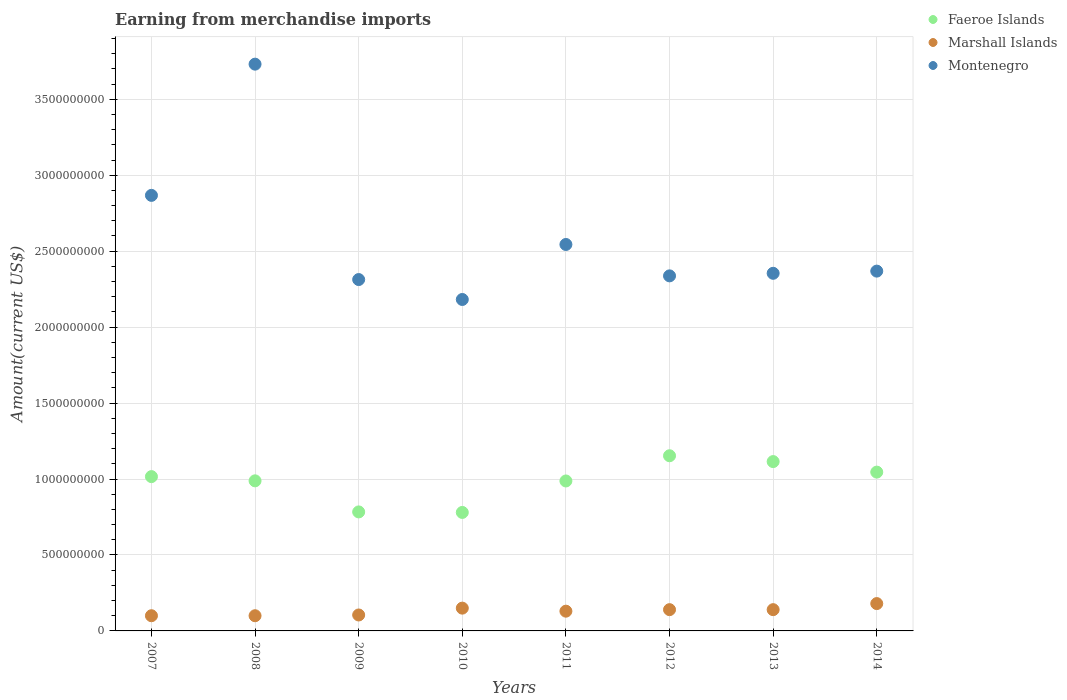How many different coloured dotlines are there?
Keep it short and to the point. 3. Is the number of dotlines equal to the number of legend labels?
Give a very brief answer. Yes. What is the amount earned from merchandise imports in Faeroe Islands in 2013?
Offer a terse response. 1.11e+09. Across all years, what is the maximum amount earned from merchandise imports in Marshall Islands?
Your answer should be compact. 1.80e+08. Across all years, what is the minimum amount earned from merchandise imports in Faeroe Islands?
Offer a very short reply. 7.80e+08. In which year was the amount earned from merchandise imports in Faeroe Islands maximum?
Give a very brief answer. 2012. In which year was the amount earned from merchandise imports in Marshall Islands minimum?
Provide a short and direct response. 2007. What is the total amount earned from merchandise imports in Marshall Islands in the graph?
Your answer should be very brief. 1.04e+09. What is the difference between the amount earned from merchandise imports in Marshall Islands in 2009 and that in 2014?
Make the answer very short. -7.50e+07. What is the difference between the amount earned from merchandise imports in Faeroe Islands in 2011 and the amount earned from merchandise imports in Marshall Islands in 2010?
Provide a short and direct response. 8.37e+08. What is the average amount earned from merchandise imports in Faeroe Islands per year?
Provide a short and direct response. 9.83e+08. In the year 2008, what is the difference between the amount earned from merchandise imports in Montenegro and amount earned from merchandise imports in Faeroe Islands?
Provide a short and direct response. 2.74e+09. What is the ratio of the amount earned from merchandise imports in Faeroe Islands in 2008 to that in 2014?
Make the answer very short. 0.95. Is the amount earned from merchandise imports in Montenegro in 2007 less than that in 2013?
Offer a terse response. No. Is the difference between the amount earned from merchandise imports in Montenegro in 2010 and 2011 greater than the difference between the amount earned from merchandise imports in Faeroe Islands in 2010 and 2011?
Make the answer very short. No. What is the difference between the highest and the second highest amount earned from merchandise imports in Faeroe Islands?
Offer a terse response. 3.84e+07. What is the difference between the highest and the lowest amount earned from merchandise imports in Faeroe Islands?
Provide a short and direct response. 3.73e+08. Is the sum of the amount earned from merchandise imports in Faeroe Islands in 2007 and 2014 greater than the maximum amount earned from merchandise imports in Montenegro across all years?
Provide a succinct answer. No. Is the amount earned from merchandise imports in Montenegro strictly less than the amount earned from merchandise imports in Marshall Islands over the years?
Make the answer very short. No. How many dotlines are there?
Provide a short and direct response. 3. What is the difference between two consecutive major ticks on the Y-axis?
Your answer should be compact. 5.00e+08. Where does the legend appear in the graph?
Give a very brief answer. Top right. How are the legend labels stacked?
Make the answer very short. Vertical. What is the title of the graph?
Keep it short and to the point. Earning from merchandise imports. What is the label or title of the Y-axis?
Keep it short and to the point. Amount(current US$). What is the Amount(current US$) in Faeroe Islands in 2007?
Provide a short and direct response. 1.02e+09. What is the Amount(current US$) in Montenegro in 2007?
Your response must be concise. 2.87e+09. What is the Amount(current US$) in Faeroe Islands in 2008?
Offer a very short reply. 9.88e+08. What is the Amount(current US$) of Montenegro in 2008?
Provide a short and direct response. 3.73e+09. What is the Amount(current US$) of Faeroe Islands in 2009?
Your answer should be compact. 7.83e+08. What is the Amount(current US$) in Marshall Islands in 2009?
Offer a terse response. 1.05e+08. What is the Amount(current US$) in Montenegro in 2009?
Your answer should be compact. 2.31e+09. What is the Amount(current US$) in Faeroe Islands in 2010?
Make the answer very short. 7.80e+08. What is the Amount(current US$) in Marshall Islands in 2010?
Make the answer very short. 1.50e+08. What is the Amount(current US$) in Montenegro in 2010?
Your answer should be compact. 2.18e+09. What is the Amount(current US$) in Faeroe Islands in 2011?
Offer a terse response. 9.87e+08. What is the Amount(current US$) in Marshall Islands in 2011?
Make the answer very short. 1.30e+08. What is the Amount(current US$) in Montenegro in 2011?
Offer a very short reply. 2.54e+09. What is the Amount(current US$) of Faeroe Islands in 2012?
Your response must be concise. 1.15e+09. What is the Amount(current US$) of Marshall Islands in 2012?
Keep it short and to the point. 1.40e+08. What is the Amount(current US$) in Montenegro in 2012?
Give a very brief answer. 2.34e+09. What is the Amount(current US$) of Faeroe Islands in 2013?
Ensure brevity in your answer.  1.11e+09. What is the Amount(current US$) in Marshall Islands in 2013?
Make the answer very short. 1.40e+08. What is the Amount(current US$) in Montenegro in 2013?
Keep it short and to the point. 2.35e+09. What is the Amount(current US$) in Faeroe Islands in 2014?
Offer a terse response. 1.05e+09. What is the Amount(current US$) in Marshall Islands in 2014?
Give a very brief answer. 1.80e+08. What is the Amount(current US$) of Montenegro in 2014?
Provide a succinct answer. 2.37e+09. Across all years, what is the maximum Amount(current US$) in Faeroe Islands?
Your answer should be compact. 1.15e+09. Across all years, what is the maximum Amount(current US$) of Marshall Islands?
Give a very brief answer. 1.80e+08. Across all years, what is the maximum Amount(current US$) in Montenegro?
Keep it short and to the point. 3.73e+09. Across all years, what is the minimum Amount(current US$) in Faeroe Islands?
Give a very brief answer. 7.80e+08. Across all years, what is the minimum Amount(current US$) in Marshall Islands?
Provide a succinct answer. 1.00e+08. Across all years, what is the minimum Amount(current US$) of Montenegro?
Give a very brief answer. 2.18e+09. What is the total Amount(current US$) in Faeroe Islands in the graph?
Offer a terse response. 7.87e+09. What is the total Amount(current US$) in Marshall Islands in the graph?
Your response must be concise. 1.04e+09. What is the total Amount(current US$) of Montenegro in the graph?
Your answer should be compact. 2.07e+1. What is the difference between the Amount(current US$) of Faeroe Islands in 2007 and that in 2008?
Ensure brevity in your answer.  2.78e+07. What is the difference between the Amount(current US$) of Montenegro in 2007 and that in 2008?
Ensure brevity in your answer.  -8.64e+08. What is the difference between the Amount(current US$) in Faeroe Islands in 2007 and that in 2009?
Make the answer very short. 2.32e+08. What is the difference between the Amount(current US$) of Marshall Islands in 2007 and that in 2009?
Provide a succinct answer. -5.00e+06. What is the difference between the Amount(current US$) of Montenegro in 2007 and that in 2009?
Offer a very short reply. 5.54e+08. What is the difference between the Amount(current US$) of Faeroe Islands in 2007 and that in 2010?
Provide a short and direct response. 2.36e+08. What is the difference between the Amount(current US$) of Marshall Islands in 2007 and that in 2010?
Your answer should be very brief. -5.00e+07. What is the difference between the Amount(current US$) in Montenegro in 2007 and that in 2010?
Your answer should be compact. 6.85e+08. What is the difference between the Amount(current US$) of Faeroe Islands in 2007 and that in 2011?
Ensure brevity in your answer.  2.86e+07. What is the difference between the Amount(current US$) of Marshall Islands in 2007 and that in 2011?
Your answer should be compact. -3.00e+07. What is the difference between the Amount(current US$) of Montenegro in 2007 and that in 2011?
Provide a succinct answer. 3.23e+08. What is the difference between the Amount(current US$) of Faeroe Islands in 2007 and that in 2012?
Your answer should be very brief. -1.37e+08. What is the difference between the Amount(current US$) in Marshall Islands in 2007 and that in 2012?
Your answer should be very brief. -4.00e+07. What is the difference between the Amount(current US$) of Montenegro in 2007 and that in 2012?
Keep it short and to the point. 5.30e+08. What is the difference between the Amount(current US$) in Faeroe Islands in 2007 and that in 2013?
Your answer should be compact. -9.89e+07. What is the difference between the Amount(current US$) of Marshall Islands in 2007 and that in 2013?
Keep it short and to the point. -4.00e+07. What is the difference between the Amount(current US$) in Montenegro in 2007 and that in 2013?
Your answer should be very brief. 5.13e+08. What is the difference between the Amount(current US$) in Faeroe Islands in 2007 and that in 2014?
Ensure brevity in your answer.  -2.96e+07. What is the difference between the Amount(current US$) in Marshall Islands in 2007 and that in 2014?
Make the answer very short. -8.00e+07. What is the difference between the Amount(current US$) of Montenegro in 2007 and that in 2014?
Provide a succinct answer. 4.99e+08. What is the difference between the Amount(current US$) of Faeroe Islands in 2008 and that in 2009?
Give a very brief answer. 2.05e+08. What is the difference between the Amount(current US$) in Marshall Islands in 2008 and that in 2009?
Your answer should be very brief. -5.00e+06. What is the difference between the Amount(current US$) of Montenegro in 2008 and that in 2009?
Provide a short and direct response. 1.42e+09. What is the difference between the Amount(current US$) of Faeroe Islands in 2008 and that in 2010?
Make the answer very short. 2.08e+08. What is the difference between the Amount(current US$) of Marshall Islands in 2008 and that in 2010?
Provide a succinct answer. -5.00e+07. What is the difference between the Amount(current US$) in Montenegro in 2008 and that in 2010?
Make the answer very short. 1.55e+09. What is the difference between the Amount(current US$) in Faeroe Islands in 2008 and that in 2011?
Offer a terse response. 8.75e+05. What is the difference between the Amount(current US$) of Marshall Islands in 2008 and that in 2011?
Your answer should be very brief. -3.00e+07. What is the difference between the Amount(current US$) in Montenegro in 2008 and that in 2011?
Offer a very short reply. 1.19e+09. What is the difference between the Amount(current US$) of Faeroe Islands in 2008 and that in 2012?
Your response must be concise. -1.65e+08. What is the difference between the Amount(current US$) of Marshall Islands in 2008 and that in 2012?
Your response must be concise. -4.00e+07. What is the difference between the Amount(current US$) of Montenegro in 2008 and that in 2012?
Offer a very short reply. 1.39e+09. What is the difference between the Amount(current US$) of Faeroe Islands in 2008 and that in 2013?
Give a very brief answer. -1.27e+08. What is the difference between the Amount(current US$) of Marshall Islands in 2008 and that in 2013?
Your answer should be compact. -4.00e+07. What is the difference between the Amount(current US$) of Montenegro in 2008 and that in 2013?
Give a very brief answer. 1.38e+09. What is the difference between the Amount(current US$) of Faeroe Islands in 2008 and that in 2014?
Your answer should be compact. -5.74e+07. What is the difference between the Amount(current US$) of Marshall Islands in 2008 and that in 2014?
Give a very brief answer. -8.00e+07. What is the difference between the Amount(current US$) of Montenegro in 2008 and that in 2014?
Give a very brief answer. 1.36e+09. What is the difference between the Amount(current US$) of Faeroe Islands in 2009 and that in 2010?
Keep it short and to the point. 3.42e+06. What is the difference between the Amount(current US$) in Marshall Islands in 2009 and that in 2010?
Provide a short and direct response. -4.50e+07. What is the difference between the Amount(current US$) of Montenegro in 2009 and that in 2010?
Provide a succinct answer. 1.31e+08. What is the difference between the Amount(current US$) of Faeroe Islands in 2009 and that in 2011?
Keep it short and to the point. -2.04e+08. What is the difference between the Amount(current US$) of Marshall Islands in 2009 and that in 2011?
Provide a succinct answer. -2.50e+07. What is the difference between the Amount(current US$) in Montenegro in 2009 and that in 2011?
Offer a very short reply. -2.31e+08. What is the difference between the Amount(current US$) in Faeroe Islands in 2009 and that in 2012?
Provide a short and direct response. -3.70e+08. What is the difference between the Amount(current US$) of Marshall Islands in 2009 and that in 2012?
Provide a short and direct response. -3.50e+07. What is the difference between the Amount(current US$) in Montenegro in 2009 and that in 2012?
Your answer should be very brief. -2.43e+07. What is the difference between the Amount(current US$) of Faeroe Islands in 2009 and that in 2013?
Ensure brevity in your answer.  -3.31e+08. What is the difference between the Amount(current US$) in Marshall Islands in 2009 and that in 2013?
Your response must be concise. -3.50e+07. What is the difference between the Amount(current US$) in Montenegro in 2009 and that in 2013?
Make the answer very short. -4.11e+07. What is the difference between the Amount(current US$) of Faeroe Islands in 2009 and that in 2014?
Keep it short and to the point. -2.62e+08. What is the difference between the Amount(current US$) in Marshall Islands in 2009 and that in 2014?
Make the answer very short. -7.50e+07. What is the difference between the Amount(current US$) of Montenegro in 2009 and that in 2014?
Offer a terse response. -5.56e+07. What is the difference between the Amount(current US$) in Faeroe Islands in 2010 and that in 2011?
Keep it short and to the point. -2.07e+08. What is the difference between the Amount(current US$) of Montenegro in 2010 and that in 2011?
Give a very brief answer. -3.62e+08. What is the difference between the Amount(current US$) in Faeroe Islands in 2010 and that in 2012?
Your response must be concise. -3.73e+08. What is the difference between the Amount(current US$) of Montenegro in 2010 and that in 2012?
Ensure brevity in your answer.  -1.55e+08. What is the difference between the Amount(current US$) in Faeroe Islands in 2010 and that in 2013?
Provide a succinct answer. -3.35e+08. What is the difference between the Amount(current US$) in Marshall Islands in 2010 and that in 2013?
Give a very brief answer. 1.00e+07. What is the difference between the Amount(current US$) of Montenegro in 2010 and that in 2013?
Give a very brief answer. -1.72e+08. What is the difference between the Amount(current US$) in Faeroe Islands in 2010 and that in 2014?
Your response must be concise. -2.65e+08. What is the difference between the Amount(current US$) of Marshall Islands in 2010 and that in 2014?
Keep it short and to the point. -3.00e+07. What is the difference between the Amount(current US$) in Montenegro in 2010 and that in 2014?
Offer a terse response. -1.87e+08. What is the difference between the Amount(current US$) of Faeroe Islands in 2011 and that in 2012?
Give a very brief answer. -1.66e+08. What is the difference between the Amount(current US$) of Marshall Islands in 2011 and that in 2012?
Provide a succinct answer. -1.00e+07. What is the difference between the Amount(current US$) of Montenegro in 2011 and that in 2012?
Offer a very short reply. 2.07e+08. What is the difference between the Amount(current US$) in Faeroe Islands in 2011 and that in 2013?
Keep it short and to the point. -1.28e+08. What is the difference between the Amount(current US$) of Marshall Islands in 2011 and that in 2013?
Offer a very short reply. -1.00e+07. What is the difference between the Amount(current US$) of Montenegro in 2011 and that in 2013?
Provide a succinct answer. 1.90e+08. What is the difference between the Amount(current US$) in Faeroe Islands in 2011 and that in 2014?
Your answer should be compact. -5.82e+07. What is the difference between the Amount(current US$) in Marshall Islands in 2011 and that in 2014?
Provide a short and direct response. -5.00e+07. What is the difference between the Amount(current US$) in Montenegro in 2011 and that in 2014?
Your response must be concise. 1.75e+08. What is the difference between the Amount(current US$) in Faeroe Islands in 2012 and that in 2013?
Your response must be concise. 3.84e+07. What is the difference between the Amount(current US$) of Montenegro in 2012 and that in 2013?
Give a very brief answer. -1.69e+07. What is the difference between the Amount(current US$) in Faeroe Islands in 2012 and that in 2014?
Provide a succinct answer. 1.08e+08. What is the difference between the Amount(current US$) in Marshall Islands in 2012 and that in 2014?
Offer a terse response. -4.00e+07. What is the difference between the Amount(current US$) in Montenegro in 2012 and that in 2014?
Provide a succinct answer. -3.13e+07. What is the difference between the Amount(current US$) of Faeroe Islands in 2013 and that in 2014?
Offer a very short reply. 6.93e+07. What is the difference between the Amount(current US$) of Marshall Islands in 2013 and that in 2014?
Your response must be concise. -4.00e+07. What is the difference between the Amount(current US$) of Montenegro in 2013 and that in 2014?
Your response must be concise. -1.44e+07. What is the difference between the Amount(current US$) in Faeroe Islands in 2007 and the Amount(current US$) in Marshall Islands in 2008?
Your response must be concise. 9.16e+08. What is the difference between the Amount(current US$) in Faeroe Islands in 2007 and the Amount(current US$) in Montenegro in 2008?
Keep it short and to the point. -2.72e+09. What is the difference between the Amount(current US$) of Marshall Islands in 2007 and the Amount(current US$) of Montenegro in 2008?
Your answer should be compact. -3.63e+09. What is the difference between the Amount(current US$) in Faeroe Islands in 2007 and the Amount(current US$) in Marshall Islands in 2009?
Keep it short and to the point. 9.11e+08. What is the difference between the Amount(current US$) in Faeroe Islands in 2007 and the Amount(current US$) in Montenegro in 2009?
Offer a very short reply. -1.30e+09. What is the difference between the Amount(current US$) in Marshall Islands in 2007 and the Amount(current US$) in Montenegro in 2009?
Ensure brevity in your answer.  -2.21e+09. What is the difference between the Amount(current US$) in Faeroe Islands in 2007 and the Amount(current US$) in Marshall Islands in 2010?
Offer a terse response. 8.66e+08. What is the difference between the Amount(current US$) in Faeroe Islands in 2007 and the Amount(current US$) in Montenegro in 2010?
Keep it short and to the point. -1.17e+09. What is the difference between the Amount(current US$) of Marshall Islands in 2007 and the Amount(current US$) of Montenegro in 2010?
Offer a very short reply. -2.08e+09. What is the difference between the Amount(current US$) of Faeroe Islands in 2007 and the Amount(current US$) of Marshall Islands in 2011?
Offer a terse response. 8.86e+08. What is the difference between the Amount(current US$) of Faeroe Islands in 2007 and the Amount(current US$) of Montenegro in 2011?
Provide a succinct answer. -1.53e+09. What is the difference between the Amount(current US$) of Marshall Islands in 2007 and the Amount(current US$) of Montenegro in 2011?
Your answer should be compact. -2.44e+09. What is the difference between the Amount(current US$) of Faeroe Islands in 2007 and the Amount(current US$) of Marshall Islands in 2012?
Ensure brevity in your answer.  8.76e+08. What is the difference between the Amount(current US$) in Faeroe Islands in 2007 and the Amount(current US$) in Montenegro in 2012?
Make the answer very short. -1.32e+09. What is the difference between the Amount(current US$) in Marshall Islands in 2007 and the Amount(current US$) in Montenegro in 2012?
Provide a succinct answer. -2.24e+09. What is the difference between the Amount(current US$) in Faeroe Islands in 2007 and the Amount(current US$) in Marshall Islands in 2013?
Your response must be concise. 8.76e+08. What is the difference between the Amount(current US$) of Faeroe Islands in 2007 and the Amount(current US$) of Montenegro in 2013?
Give a very brief answer. -1.34e+09. What is the difference between the Amount(current US$) of Marshall Islands in 2007 and the Amount(current US$) of Montenegro in 2013?
Your answer should be very brief. -2.25e+09. What is the difference between the Amount(current US$) of Faeroe Islands in 2007 and the Amount(current US$) of Marshall Islands in 2014?
Keep it short and to the point. 8.36e+08. What is the difference between the Amount(current US$) in Faeroe Islands in 2007 and the Amount(current US$) in Montenegro in 2014?
Offer a terse response. -1.35e+09. What is the difference between the Amount(current US$) in Marshall Islands in 2007 and the Amount(current US$) in Montenegro in 2014?
Make the answer very short. -2.27e+09. What is the difference between the Amount(current US$) of Faeroe Islands in 2008 and the Amount(current US$) of Marshall Islands in 2009?
Your response must be concise. 8.83e+08. What is the difference between the Amount(current US$) in Faeroe Islands in 2008 and the Amount(current US$) in Montenegro in 2009?
Your answer should be very brief. -1.33e+09. What is the difference between the Amount(current US$) in Marshall Islands in 2008 and the Amount(current US$) in Montenegro in 2009?
Ensure brevity in your answer.  -2.21e+09. What is the difference between the Amount(current US$) in Faeroe Islands in 2008 and the Amount(current US$) in Marshall Islands in 2010?
Offer a very short reply. 8.38e+08. What is the difference between the Amount(current US$) in Faeroe Islands in 2008 and the Amount(current US$) in Montenegro in 2010?
Make the answer very short. -1.19e+09. What is the difference between the Amount(current US$) in Marshall Islands in 2008 and the Amount(current US$) in Montenegro in 2010?
Provide a succinct answer. -2.08e+09. What is the difference between the Amount(current US$) of Faeroe Islands in 2008 and the Amount(current US$) of Marshall Islands in 2011?
Your answer should be very brief. 8.58e+08. What is the difference between the Amount(current US$) in Faeroe Islands in 2008 and the Amount(current US$) in Montenegro in 2011?
Keep it short and to the point. -1.56e+09. What is the difference between the Amount(current US$) in Marshall Islands in 2008 and the Amount(current US$) in Montenegro in 2011?
Keep it short and to the point. -2.44e+09. What is the difference between the Amount(current US$) in Faeroe Islands in 2008 and the Amount(current US$) in Marshall Islands in 2012?
Your answer should be compact. 8.48e+08. What is the difference between the Amount(current US$) of Faeroe Islands in 2008 and the Amount(current US$) of Montenegro in 2012?
Make the answer very short. -1.35e+09. What is the difference between the Amount(current US$) in Marshall Islands in 2008 and the Amount(current US$) in Montenegro in 2012?
Give a very brief answer. -2.24e+09. What is the difference between the Amount(current US$) in Faeroe Islands in 2008 and the Amount(current US$) in Marshall Islands in 2013?
Your response must be concise. 8.48e+08. What is the difference between the Amount(current US$) in Faeroe Islands in 2008 and the Amount(current US$) in Montenegro in 2013?
Your response must be concise. -1.37e+09. What is the difference between the Amount(current US$) of Marshall Islands in 2008 and the Amount(current US$) of Montenegro in 2013?
Offer a terse response. -2.25e+09. What is the difference between the Amount(current US$) of Faeroe Islands in 2008 and the Amount(current US$) of Marshall Islands in 2014?
Ensure brevity in your answer.  8.08e+08. What is the difference between the Amount(current US$) in Faeroe Islands in 2008 and the Amount(current US$) in Montenegro in 2014?
Provide a short and direct response. -1.38e+09. What is the difference between the Amount(current US$) in Marshall Islands in 2008 and the Amount(current US$) in Montenegro in 2014?
Offer a terse response. -2.27e+09. What is the difference between the Amount(current US$) in Faeroe Islands in 2009 and the Amount(current US$) in Marshall Islands in 2010?
Give a very brief answer. 6.33e+08. What is the difference between the Amount(current US$) in Faeroe Islands in 2009 and the Amount(current US$) in Montenegro in 2010?
Your response must be concise. -1.40e+09. What is the difference between the Amount(current US$) of Marshall Islands in 2009 and the Amount(current US$) of Montenegro in 2010?
Provide a succinct answer. -2.08e+09. What is the difference between the Amount(current US$) of Faeroe Islands in 2009 and the Amount(current US$) of Marshall Islands in 2011?
Give a very brief answer. 6.53e+08. What is the difference between the Amount(current US$) of Faeroe Islands in 2009 and the Amount(current US$) of Montenegro in 2011?
Your response must be concise. -1.76e+09. What is the difference between the Amount(current US$) of Marshall Islands in 2009 and the Amount(current US$) of Montenegro in 2011?
Your answer should be very brief. -2.44e+09. What is the difference between the Amount(current US$) in Faeroe Islands in 2009 and the Amount(current US$) in Marshall Islands in 2012?
Provide a succinct answer. 6.43e+08. What is the difference between the Amount(current US$) of Faeroe Islands in 2009 and the Amount(current US$) of Montenegro in 2012?
Make the answer very short. -1.55e+09. What is the difference between the Amount(current US$) in Marshall Islands in 2009 and the Amount(current US$) in Montenegro in 2012?
Your answer should be very brief. -2.23e+09. What is the difference between the Amount(current US$) of Faeroe Islands in 2009 and the Amount(current US$) of Marshall Islands in 2013?
Your answer should be very brief. 6.43e+08. What is the difference between the Amount(current US$) in Faeroe Islands in 2009 and the Amount(current US$) in Montenegro in 2013?
Provide a succinct answer. -1.57e+09. What is the difference between the Amount(current US$) of Marshall Islands in 2009 and the Amount(current US$) of Montenegro in 2013?
Give a very brief answer. -2.25e+09. What is the difference between the Amount(current US$) of Faeroe Islands in 2009 and the Amount(current US$) of Marshall Islands in 2014?
Give a very brief answer. 6.03e+08. What is the difference between the Amount(current US$) in Faeroe Islands in 2009 and the Amount(current US$) in Montenegro in 2014?
Provide a succinct answer. -1.59e+09. What is the difference between the Amount(current US$) of Marshall Islands in 2009 and the Amount(current US$) of Montenegro in 2014?
Provide a succinct answer. -2.26e+09. What is the difference between the Amount(current US$) in Faeroe Islands in 2010 and the Amount(current US$) in Marshall Islands in 2011?
Offer a terse response. 6.50e+08. What is the difference between the Amount(current US$) in Faeroe Islands in 2010 and the Amount(current US$) in Montenegro in 2011?
Keep it short and to the point. -1.76e+09. What is the difference between the Amount(current US$) in Marshall Islands in 2010 and the Amount(current US$) in Montenegro in 2011?
Your response must be concise. -2.39e+09. What is the difference between the Amount(current US$) of Faeroe Islands in 2010 and the Amount(current US$) of Marshall Islands in 2012?
Your answer should be compact. 6.40e+08. What is the difference between the Amount(current US$) in Faeroe Islands in 2010 and the Amount(current US$) in Montenegro in 2012?
Offer a very short reply. -1.56e+09. What is the difference between the Amount(current US$) in Marshall Islands in 2010 and the Amount(current US$) in Montenegro in 2012?
Your answer should be very brief. -2.19e+09. What is the difference between the Amount(current US$) in Faeroe Islands in 2010 and the Amount(current US$) in Marshall Islands in 2013?
Offer a terse response. 6.40e+08. What is the difference between the Amount(current US$) of Faeroe Islands in 2010 and the Amount(current US$) of Montenegro in 2013?
Offer a very short reply. -1.57e+09. What is the difference between the Amount(current US$) in Marshall Islands in 2010 and the Amount(current US$) in Montenegro in 2013?
Keep it short and to the point. -2.20e+09. What is the difference between the Amount(current US$) of Faeroe Islands in 2010 and the Amount(current US$) of Marshall Islands in 2014?
Your answer should be very brief. 6.00e+08. What is the difference between the Amount(current US$) in Faeroe Islands in 2010 and the Amount(current US$) in Montenegro in 2014?
Offer a terse response. -1.59e+09. What is the difference between the Amount(current US$) in Marshall Islands in 2010 and the Amount(current US$) in Montenegro in 2014?
Make the answer very short. -2.22e+09. What is the difference between the Amount(current US$) of Faeroe Islands in 2011 and the Amount(current US$) of Marshall Islands in 2012?
Ensure brevity in your answer.  8.47e+08. What is the difference between the Amount(current US$) in Faeroe Islands in 2011 and the Amount(current US$) in Montenegro in 2012?
Your answer should be compact. -1.35e+09. What is the difference between the Amount(current US$) in Marshall Islands in 2011 and the Amount(current US$) in Montenegro in 2012?
Your response must be concise. -2.21e+09. What is the difference between the Amount(current US$) of Faeroe Islands in 2011 and the Amount(current US$) of Marshall Islands in 2013?
Your answer should be very brief. 8.47e+08. What is the difference between the Amount(current US$) in Faeroe Islands in 2011 and the Amount(current US$) in Montenegro in 2013?
Your answer should be compact. -1.37e+09. What is the difference between the Amount(current US$) of Marshall Islands in 2011 and the Amount(current US$) of Montenegro in 2013?
Your response must be concise. -2.22e+09. What is the difference between the Amount(current US$) in Faeroe Islands in 2011 and the Amount(current US$) in Marshall Islands in 2014?
Make the answer very short. 8.07e+08. What is the difference between the Amount(current US$) in Faeroe Islands in 2011 and the Amount(current US$) in Montenegro in 2014?
Give a very brief answer. -1.38e+09. What is the difference between the Amount(current US$) in Marshall Islands in 2011 and the Amount(current US$) in Montenegro in 2014?
Offer a terse response. -2.24e+09. What is the difference between the Amount(current US$) of Faeroe Islands in 2012 and the Amount(current US$) of Marshall Islands in 2013?
Keep it short and to the point. 1.01e+09. What is the difference between the Amount(current US$) of Faeroe Islands in 2012 and the Amount(current US$) of Montenegro in 2013?
Make the answer very short. -1.20e+09. What is the difference between the Amount(current US$) of Marshall Islands in 2012 and the Amount(current US$) of Montenegro in 2013?
Provide a short and direct response. -2.21e+09. What is the difference between the Amount(current US$) in Faeroe Islands in 2012 and the Amount(current US$) in Marshall Islands in 2014?
Offer a very short reply. 9.73e+08. What is the difference between the Amount(current US$) of Faeroe Islands in 2012 and the Amount(current US$) of Montenegro in 2014?
Give a very brief answer. -1.22e+09. What is the difference between the Amount(current US$) in Marshall Islands in 2012 and the Amount(current US$) in Montenegro in 2014?
Offer a terse response. -2.23e+09. What is the difference between the Amount(current US$) in Faeroe Islands in 2013 and the Amount(current US$) in Marshall Islands in 2014?
Ensure brevity in your answer.  9.35e+08. What is the difference between the Amount(current US$) in Faeroe Islands in 2013 and the Amount(current US$) in Montenegro in 2014?
Ensure brevity in your answer.  -1.25e+09. What is the difference between the Amount(current US$) in Marshall Islands in 2013 and the Amount(current US$) in Montenegro in 2014?
Give a very brief answer. -2.23e+09. What is the average Amount(current US$) in Faeroe Islands per year?
Your answer should be very brief. 9.83e+08. What is the average Amount(current US$) of Marshall Islands per year?
Make the answer very short. 1.31e+08. What is the average Amount(current US$) of Montenegro per year?
Provide a short and direct response. 2.59e+09. In the year 2007, what is the difference between the Amount(current US$) of Faeroe Islands and Amount(current US$) of Marshall Islands?
Provide a short and direct response. 9.16e+08. In the year 2007, what is the difference between the Amount(current US$) of Faeroe Islands and Amount(current US$) of Montenegro?
Your response must be concise. -1.85e+09. In the year 2007, what is the difference between the Amount(current US$) of Marshall Islands and Amount(current US$) of Montenegro?
Offer a very short reply. -2.77e+09. In the year 2008, what is the difference between the Amount(current US$) in Faeroe Islands and Amount(current US$) in Marshall Islands?
Offer a very short reply. 8.88e+08. In the year 2008, what is the difference between the Amount(current US$) in Faeroe Islands and Amount(current US$) in Montenegro?
Give a very brief answer. -2.74e+09. In the year 2008, what is the difference between the Amount(current US$) of Marshall Islands and Amount(current US$) of Montenegro?
Offer a terse response. -3.63e+09. In the year 2009, what is the difference between the Amount(current US$) in Faeroe Islands and Amount(current US$) in Marshall Islands?
Provide a short and direct response. 6.78e+08. In the year 2009, what is the difference between the Amount(current US$) of Faeroe Islands and Amount(current US$) of Montenegro?
Provide a short and direct response. -1.53e+09. In the year 2009, what is the difference between the Amount(current US$) in Marshall Islands and Amount(current US$) in Montenegro?
Your answer should be compact. -2.21e+09. In the year 2010, what is the difference between the Amount(current US$) of Faeroe Islands and Amount(current US$) of Marshall Islands?
Give a very brief answer. 6.30e+08. In the year 2010, what is the difference between the Amount(current US$) of Faeroe Islands and Amount(current US$) of Montenegro?
Your answer should be very brief. -1.40e+09. In the year 2010, what is the difference between the Amount(current US$) of Marshall Islands and Amount(current US$) of Montenegro?
Give a very brief answer. -2.03e+09. In the year 2011, what is the difference between the Amount(current US$) of Faeroe Islands and Amount(current US$) of Marshall Islands?
Offer a terse response. 8.57e+08. In the year 2011, what is the difference between the Amount(current US$) in Faeroe Islands and Amount(current US$) in Montenegro?
Your answer should be very brief. -1.56e+09. In the year 2011, what is the difference between the Amount(current US$) of Marshall Islands and Amount(current US$) of Montenegro?
Give a very brief answer. -2.41e+09. In the year 2012, what is the difference between the Amount(current US$) in Faeroe Islands and Amount(current US$) in Marshall Islands?
Offer a very short reply. 1.01e+09. In the year 2012, what is the difference between the Amount(current US$) in Faeroe Islands and Amount(current US$) in Montenegro?
Keep it short and to the point. -1.18e+09. In the year 2012, what is the difference between the Amount(current US$) of Marshall Islands and Amount(current US$) of Montenegro?
Offer a terse response. -2.20e+09. In the year 2013, what is the difference between the Amount(current US$) of Faeroe Islands and Amount(current US$) of Marshall Islands?
Provide a succinct answer. 9.75e+08. In the year 2013, what is the difference between the Amount(current US$) of Faeroe Islands and Amount(current US$) of Montenegro?
Provide a short and direct response. -1.24e+09. In the year 2013, what is the difference between the Amount(current US$) in Marshall Islands and Amount(current US$) in Montenegro?
Keep it short and to the point. -2.21e+09. In the year 2014, what is the difference between the Amount(current US$) of Faeroe Islands and Amount(current US$) of Marshall Islands?
Offer a terse response. 8.65e+08. In the year 2014, what is the difference between the Amount(current US$) of Faeroe Islands and Amount(current US$) of Montenegro?
Provide a succinct answer. -1.32e+09. In the year 2014, what is the difference between the Amount(current US$) in Marshall Islands and Amount(current US$) in Montenegro?
Your answer should be compact. -2.19e+09. What is the ratio of the Amount(current US$) in Faeroe Islands in 2007 to that in 2008?
Make the answer very short. 1.03. What is the ratio of the Amount(current US$) of Montenegro in 2007 to that in 2008?
Your answer should be very brief. 0.77. What is the ratio of the Amount(current US$) of Faeroe Islands in 2007 to that in 2009?
Make the answer very short. 1.3. What is the ratio of the Amount(current US$) in Montenegro in 2007 to that in 2009?
Your answer should be very brief. 1.24. What is the ratio of the Amount(current US$) of Faeroe Islands in 2007 to that in 2010?
Give a very brief answer. 1.3. What is the ratio of the Amount(current US$) of Montenegro in 2007 to that in 2010?
Make the answer very short. 1.31. What is the ratio of the Amount(current US$) in Marshall Islands in 2007 to that in 2011?
Make the answer very short. 0.77. What is the ratio of the Amount(current US$) of Montenegro in 2007 to that in 2011?
Your answer should be very brief. 1.13. What is the ratio of the Amount(current US$) in Faeroe Islands in 2007 to that in 2012?
Keep it short and to the point. 0.88. What is the ratio of the Amount(current US$) in Marshall Islands in 2007 to that in 2012?
Your answer should be compact. 0.71. What is the ratio of the Amount(current US$) of Montenegro in 2007 to that in 2012?
Offer a terse response. 1.23. What is the ratio of the Amount(current US$) of Faeroe Islands in 2007 to that in 2013?
Offer a very short reply. 0.91. What is the ratio of the Amount(current US$) of Marshall Islands in 2007 to that in 2013?
Your response must be concise. 0.71. What is the ratio of the Amount(current US$) of Montenegro in 2007 to that in 2013?
Your answer should be compact. 1.22. What is the ratio of the Amount(current US$) of Faeroe Islands in 2007 to that in 2014?
Your response must be concise. 0.97. What is the ratio of the Amount(current US$) in Marshall Islands in 2007 to that in 2014?
Your response must be concise. 0.56. What is the ratio of the Amount(current US$) in Montenegro in 2007 to that in 2014?
Offer a terse response. 1.21. What is the ratio of the Amount(current US$) of Faeroe Islands in 2008 to that in 2009?
Your answer should be compact. 1.26. What is the ratio of the Amount(current US$) of Marshall Islands in 2008 to that in 2009?
Offer a terse response. 0.95. What is the ratio of the Amount(current US$) of Montenegro in 2008 to that in 2009?
Make the answer very short. 1.61. What is the ratio of the Amount(current US$) in Faeroe Islands in 2008 to that in 2010?
Offer a very short reply. 1.27. What is the ratio of the Amount(current US$) in Marshall Islands in 2008 to that in 2010?
Your answer should be compact. 0.67. What is the ratio of the Amount(current US$) in Montenegro in 2008 to that in 2010?
Keep it short and to the point. 1.71. What is the ratio of the Amount(current US$) of Faeroe Islands in 2008 to that in 2011?
Provide a short and direct response. 1. What is the ratio of the Amount(current US$) in Marshall Islands in 2008 to that in 2011?
Give a very brief answer. 0.77. What is the ratio of the Amount(current US$) of Montenegro in 2008 to that in 2011?
Provide a short and direct response. 1.47. What is the ratio of the Amount(current US$) of Faeroe Islands in 2008 to that in 2012?
Ensure brevity in your answer.  0.86. What is the ratio of the Amount(current US$) of Marshall Islands in 2008 to that in 2012?
Offer a terse response. 0.71. What is the ratio of the Amount(current US$) in Montenegro in 2008 to that in 2012?
Your answer should be compact. 1.6. What is the ratio of the Amount(current US$) in Faeroe Islands in 2008 to that in 2013?
Your answer should be very brief. 0.89. What is the ratio of the Amount(current US$) in Marshall Islands in 2008 to that in 2013?
Offer a terse response. 0.71. What is the ratio of the Amount(current US$) of Montenegro in 2008 to that in 2013?
Your answer should be very brief. 1.58. What is the ratio of the Amount(current US$) in Faeroe Islands in 2008 to that in 2014?
Your answer should be very brief. 0.95. What is the ratio of the Amount(current US$) in Marshall Islands in 2008 to that in 2014?
Your answer should be very brief. 0.56. What is the ratio of the Amount(current US$) of Montenegro in 2008 to that in 2014?
Provide a succinct answer. 1.58. What is the ratio of the Amount(current US$) in Marshall Islands in 2009 to that in 2010?
Provide a succinct answer. 0.7. What is the ratio of the Amount(current US$) in Montenegro in 2009 to that in 2010?
Provide a succinct answer. 1.06. What is the ratio of the Amount(current US$) in Faeroe Islands in 2009 to that in 2011?
Ensure brevity in your answer.  0.79. What is the ratio of the Amount(current US$) of Marshall Islands in 2009 to that in 2011?
Keep it short and to the point. 0.81. What is the ratio of the Amount(current US$) of Montenegro in 2009 to that in 2011?
Provide a succinct answer. 0.91. What is the ratio of the Amount(current US$) of Faeroe Islands in 2009 to that in 2012?
Ensure brevity in your answer.  0.68. What is the ratio of the Amount(current US$) of Marshall Islands in 2009 to that in 2012?
Your answer should be compact. 0.75. What is the ratio of the Amount(current US$) of Montenegro in 2009 to that in 2012?
Offer a very short reply. 0.99. What is the ratio of the Amount(current US$) in Faeroe Islands in 2009 to that in 2013?
Your response must be concise. 0.7. What is the ratio of the Amount(current US$) in Montenegro in 2009 to that in 2013?
Offer a terse response. 0.98. What is the ratio of the Amount(current US$) in Faeroe Islands in 2009 to that in 2014?
Offer a terse response. 0.75. What is the ratio of the Amount(current US$) in Marshall Islands in 2009 to that in 2014?
Provide a succinct answer. 0.58. What is the ratio of the Amount(current US$) of Montenegro in 2009 to that in 2014?
Offer a terse response. 0.98. What is the ratio of the Amount(current US$) in Faeroe Islands in 2010 to that in 2011?
Keep it short and to the point. 0.79. What is the ratio of the Amount(current US$) in Marshall Islands in 2010 to that in 2011?
Provide a short and direct response. 1.15. What is the ratio of the Amount(current US$) in Montenegro in 2010 to that in 2011?
Make the answer very short. 0.86. What is the ratio of the Amount(current US$) in Faeroe Islands in 2010 to that in 2012?
Your answer should be very brief. 0.68. What is the ratio of the Amount(current US$) in Marshall Islands in 2010 to that in 2012?
Your response must be concise. 1.07. What is the ratio of the Amount(current US$) of Montenegro in 2010 to that in 2012?
Your answer should be compact. 0.93. What is the ratio of the Amount(current US$) of Faeroe Islands in 2010 to that in 2013?
Keep it short and to the point. 0.7. What is the ratio of the Amount(current US$) of Marshall Islands in 2010 to that in 2013?
Give a very brief answer. 1.07. What is the ratio of the Amount(current US$) of Montenegro in 2010 to that in 2013?
Your answer should be compact. 0.93. What is the ratio of the Amount(current US$) of Faeroe Islands in 2010 to that in 2014?
Offer a terse response. 0.75. What is the ratio of the Amount(current US$) of Montenegro in 2010 to that in 2014?
Your answer should be very brief. 0.92. What is the ratio of the Amount(current US$) of Faeroe Islands in 2011 to that in 2012?
Offer a terse response. 0.86. What is the ratio of the Amount(current US$) of Montenegro in 2011 to that in 2012?
Offer a very short reply. 1.09. What is the ratio of the Amount(current US$) in Faeroe Islands in 2011 to that in 2013?
Give a very brief answer. 0.89. What is the ratio of the Amount(current US$) of Marshall Islands in 2011 to that in 2013?
Your answer should be compact. 0.93. What is the ratio of the Amount(current US$) in Montenegro in 2011 to that in 2013?
Ensure brevity in your answer.  1.08. What is the ratio of the Amount(current US$) of Faeroe Islands in 2011 to that in 2014?
Your response must be concise. 0.94. What is the ratio of the Amount(current US$) in Marshall Islands in 2011 to that in 2014?
Make the answer very short. 0.72. What is the ratio of the Amount(current US$) in Montenegro in 2011 to that in 2014?
Make the answer very short. 1.07. What is the ratio of the Amount(current US$) of Faeroe Islands in 2012 to that in 2013?
Keep it short and to the point. 1.03. What is the ratio of the Amount(current US$) in Marshall Islands in 2012 to that in 2013?
Ensure brevity in your answer.  1. What is the ratio of the Amount(current US$) in Faeroe Islands in 2012 to that in 2014?
Offer a terse response. 1.1. What is the ratio of the Amount(current US$) in Montenegro in 2012 to that in 2014?
Give a very brief answer. 0.99. What is the ratio of the Amount(current US$) in Faeroe Islands in 2013 to that in 2014?
Offer a very short reply. 1.07. What is the ratio of the Amount(current US$) in Montenegro in 2013 to that in 2014?
Offer a very short reply. 0.99. What is the difference between the highest and the second highest Amount(current US$) in Faeroe Islands?
Your response must be concise. 3.84e+07. What is the difference between the highest and the second highest Amount(current US$) of Marshall Islands?
Offer a terse response. 3.00e+07. What is the difference between the highest and the second highest Amount(current US$) in Montenegro?
Offer a very short reply. 8.64e+08. What is the difference between the highest and the lowest Amount(current US$) in Faeroe Islands?
Provide a succinct answer. 3.73e+08. What is the difference between the highest and the lowest Amount(current US$) in Marshall Islands?
Provide a short and direct response. 8.00e+07. What is the difference between the highest and the lowest Amount(current US$) in Montenegro?
Provide a short and direct response. 1.55e+09. 